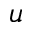Convert formula to latex. <formula><loc_0><loc_0><loc_500><loc_500>u</formula> 